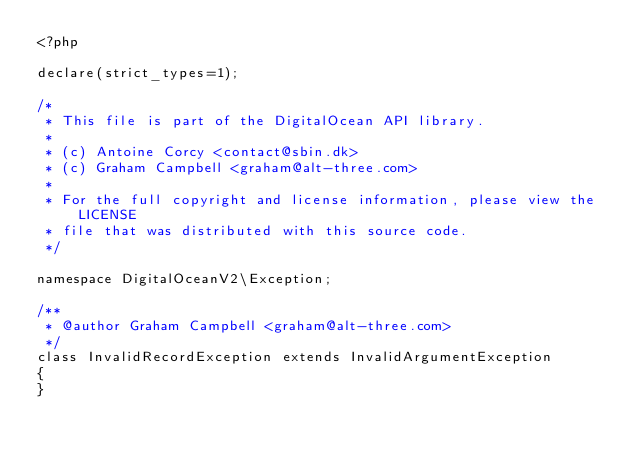<code> <loc_0><loc_0><loc_500><loc_500><_PHP_><?php

declare(strict_types=1);

/*
 * This file is part of the DigitalOcean API library.
 *
 * (c) Antoine Corcy <contact@sbin.dk>
 * (c) Graham Campbell <graham@alt-three.com>
 *
 * For the full copyright and license information, please view the LICENSE
 * file that was distributed with this source code.
 */

namespace DigitalOceanV2\Exception;

/**
 * @author Graham Campbell <graham@alt-three.com>
 */
class InvalidRecordException extends InvalidArgumentException
{
}
</code> 